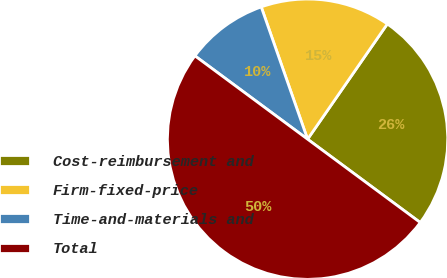<chart> <loc_0><loc_0><loc_500><loc_500><pie_chart><fcel>Cost-reimbursement and<fcel>Firm-fixed-price<fcel>Time-and-materials and<fcel>Total<nl><fcel>25.5%<fcel>15.0%<fcel>9.5%<fcel>50.0%<nl></chart> 